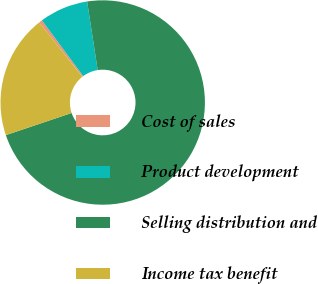Convert chart. <chart><loc_0><loc_0><loc_500><loc_500><pie_chart><fcel>Cost of sales<fcel>Product development<fcel>Selling distribution and<fcel>Income tax benefit<nl><fcel>0.53%<fcel>7.7%<fcel>72.27%<fcel>19.5%<nl></chart> 